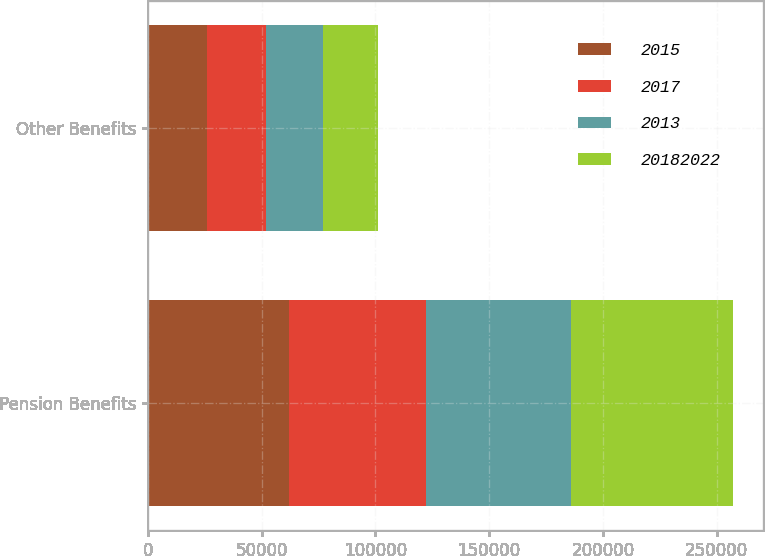Convert chart. <chart><loc_0><loc_0><loc_500><loc_500><stacked_bar_chart><ecel><fcel>Pension Benefits<fcel>Other Benefits<nl><fcel>2015<fcel>61840<fcel>26169<nl><fcel>2017<fcel>60458<fcel>25687<nl><fcel>2013<fcel>63731<fcel>25092<nl><fcel>2.0182e+07<fcel>71315<fcel>24334<nl></chart> 